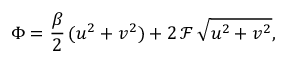Convert formula to latex. <formula><loc_0><loc_0><loc_500><loc_500>\Phi = \frac { \beta } { 2 } \, ( u ^ { 2 } + v ^ { 2 } ) + 2 \, \mathcal { F } \, \sqrt { u ^ { 2 } + v ^ { 2 } } ,</formula> 